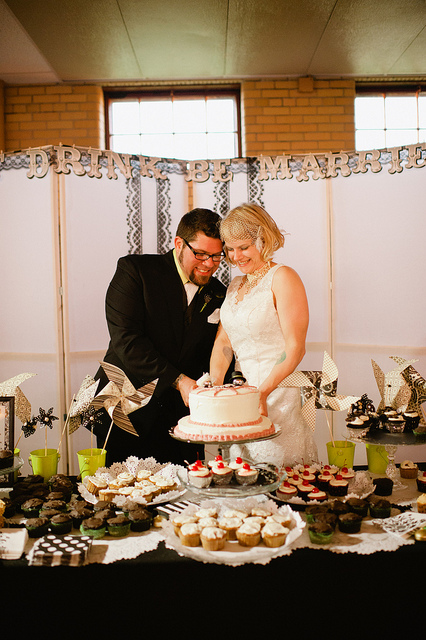What are the two touching?
A. muffins
B. brownies
C. cake
D. pie The couple in the photograph appears to be touching a cake, which is traditionally associated with wedding celebrations. Given the context provided by the image, the two are likely cutting the cake together, a common custom at weddings to symbolize the first task performed together as a married couple. 